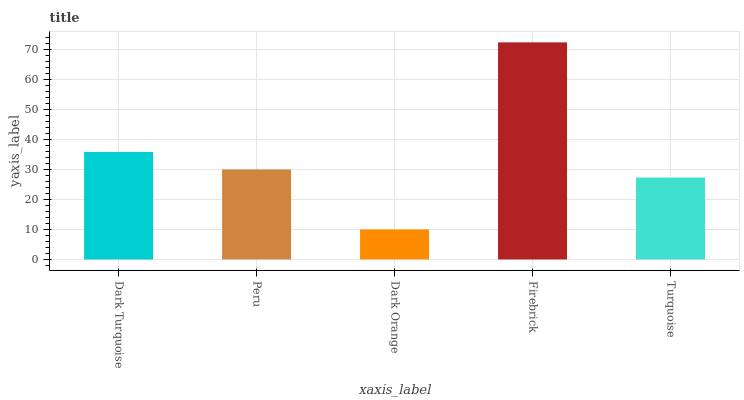Is Dark Orange the minimum?
Answer yes or no. Yes. Is Firebrick the maximum?
Answer yes or no. Yes. Is Peru the minimum?
Answer yes or no. No. Is Peru the maximum?
Answer yes or no. No. Is Dark Turquoise greater than Peru?
Answer yes or no. Yes. Is Peru less than Dark Turquoise?
Answer yes or no. Yes. Is Peru greater than Dark Turquoise?
Answer yes or no. No. Is Dark Turquoise less than Peru?
Answer yes or no. No. Is Peru the high median?
Answer yes or no. Yes. Is Peru the low median?
Answer yes or no. Yes. Is Dark Turquoise the high median?
Answer yes or no. No. Is Dark Turquoise the low median?
Answer yes or no. No. 